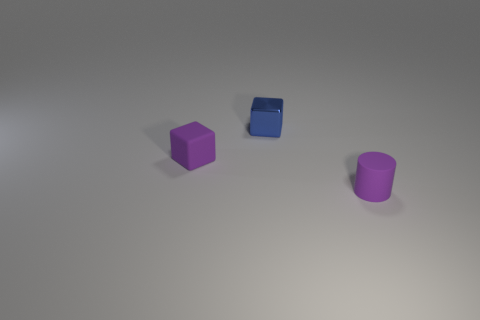There is a small block that is the same color as the tiny cylinder; what material is it?
Offer a terse response. Rubber. How many objects are rubber objects on the left side of the small blue cube or cubes behind the small purple rubber cube?
Make the answer very short. 2. Is the size of the matte cube the same as the rubber cylinder?
Make the answer very short. Yes. How many spheres are either small purple matte objects or small objects?
Provide a short and direct response. 0. What number of objects are in front of the purple rubber cube and left of the blue metal block?
Keep it short and to the point. 0. There is a matte block; does it have the same size as the purple matte object that is to the right of the small blue block?
Make the answer very short. Yes. Is there a small block that is to the left of the tiny object behind the small block in front of the small blue thing?
Make the answer very short. Yes. What is the small purple thing that is in front of the tiny rubber object to the left of the blue metal object made of?
Your response must be concise. Rubber. There is a object that is to the right of the purple matte block and behind the purple rubber cylinder; what material is it?
Provide a succinct answer. Metal. Is there another tiny blue object of the same shape as the tiny metallic thing?
Provide a short and direct response. No. 